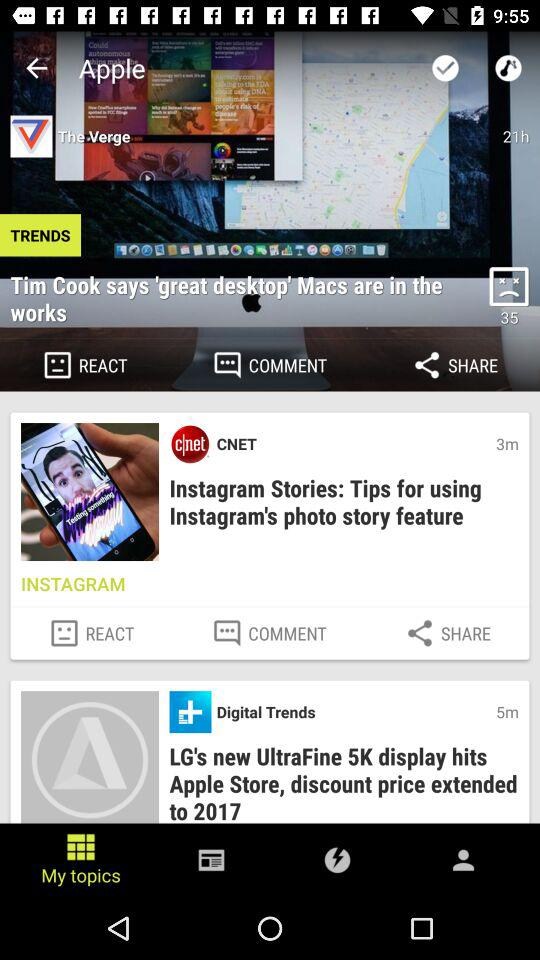Which option is selected?
When the provided information is insufficient, respond with <no answer>. <no answer> 